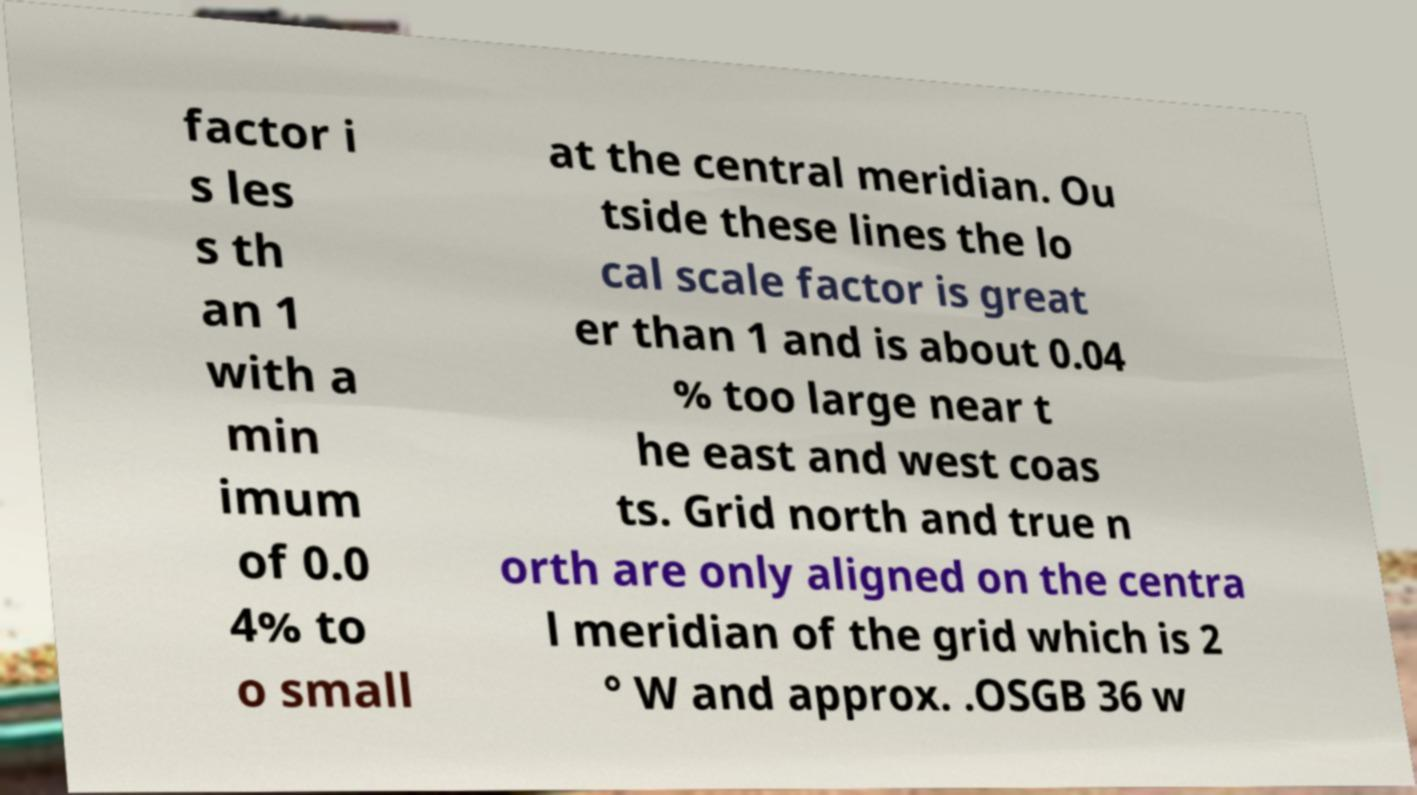Could you assist in decoding the text presented in this image and type it out clearly? factor i s les s th an 1 with a min imum of 0.0 4% to o small at the central meridian. Ou tside these lines the lo cal scale factor is great er than 1 and is about 0.04 % too large near t he east and west coas ts. Grid north and true n orth are only aligned on the centra l meridian of the grid which is 2 ° W and approx. .OSGB 36 w 